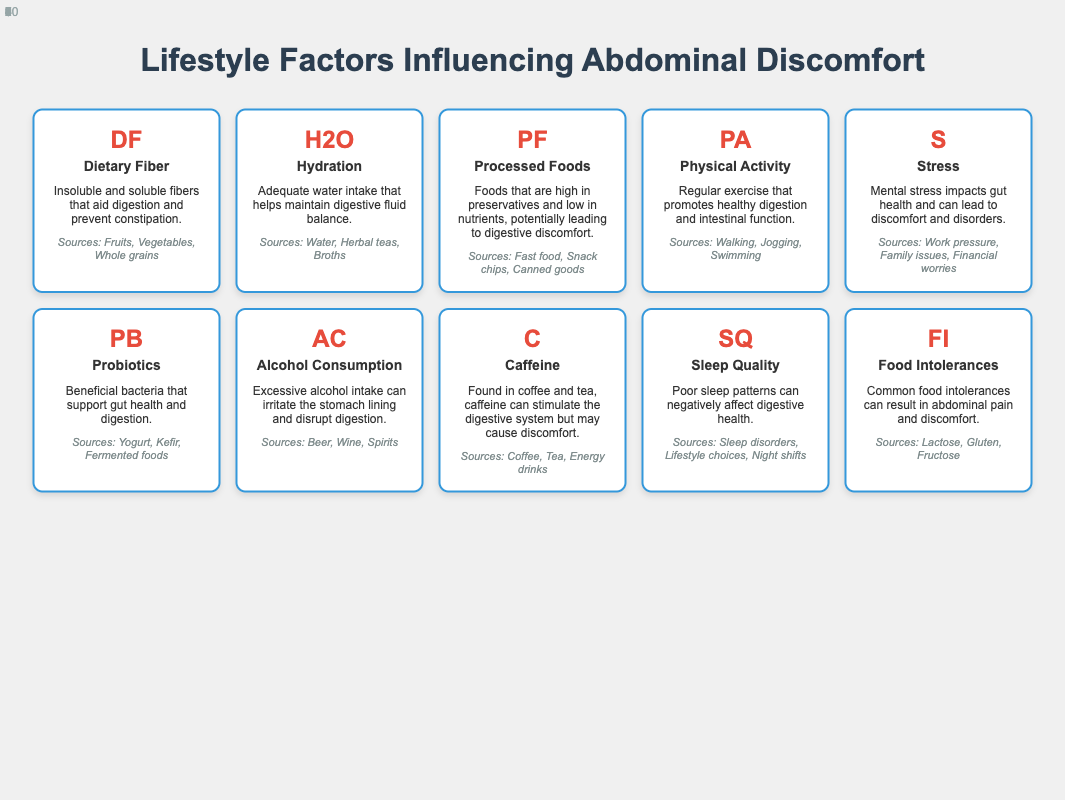What are the sources of dietary fiber? The table lists the sources of dietary fiber under the "sources" category for the Dietary Fiber element (DF). The listed sources are Fruits, Vegetables, and Whole grains.
Answer: Fruits, Vegetables, Whole grains How many elements are related to hydration in the table? The element "Hydration" (H2O) is present, and we are only asked for hydration-related content. Since there is only one explicit mention of hydration and no other element relates specifically to it, the count is one.
Answer: 1 Is physical activity a factor that can influence digestive health? Yes, the table indicates that physical activity (PA) promotes healthy digestion and intestinal function, therefore it is indeed a factor that can influence digestive health.
Answer: Yes What is the description of the "Processed Foods" element? To answer this, we refer to the description of the element "Processed Foods" (PF) in the table, which indicates that these foods are high in preservatives and low in nutrients, potentially leading to digestive discomfort.
Answer: Foods high in preservatives and low in nutrients, leading to discomfort Which sources are listed for probiotics? The sources for probiotics (PB) include Yogurt, Kefir, and Fermented foods, which are directly listed under the sources category for this element in the table.
Answer: Yogurt, Kefir, Fermented foods How do stress and poor sleep quality affect digestion? Based on the table, both stress (S) and poor sleep quality (SQ) negatively impact gut health. Stress can lead to discomfort and disorders, while poor sleep patterns can adversely affect digestive health. Therefore, both contribute negatively to digestion.
Answer: Both negatively impact digestion What is the average number of sources listed for elements in the table? Each element has a specific number of listed sources. Counting these, there are three for dietary fiber, three for hydration, three for processed foods, three for probiotics similarly, and others also tend to have three, but alcohol has three, caffeine has three, and food intolerances listed also have three. The total counts (3x10 = 30 sources) divided by the number of elements (10) yields an average of 3 sources per element.
Answer: 3 Which elements do not appear to have significant sources related to digestive health? Upon reviewing the table, one can note that all elements have defined sources related to health, but one could argue that "Stress" and "Sleep Quality" are more lifestyle-related and do not have tangible food items that directly correlate with digestive health, only implications. Therefore, these two could be seen as lacking significant sources.
Answer: Stress, Sleep Quality Does excessive alcohol consumption affect digestive health? Yes, the table clearly states that excessive alcohol consumption (AC) can irritate the stomach lining and disrupt digestion, confirming that it negatively affects digestive health.
Answer: Yes What is the impact of food intolerances on abdominal discomfort? The table indicates that common food intolerances can result in abdominal pain and discomfort, thus indicating a direct relationship between the two. There are listed examples such as lactose, gluten, and fructose, reinforcing this impact.
Answer: They result in abdominal pain and discomfort 